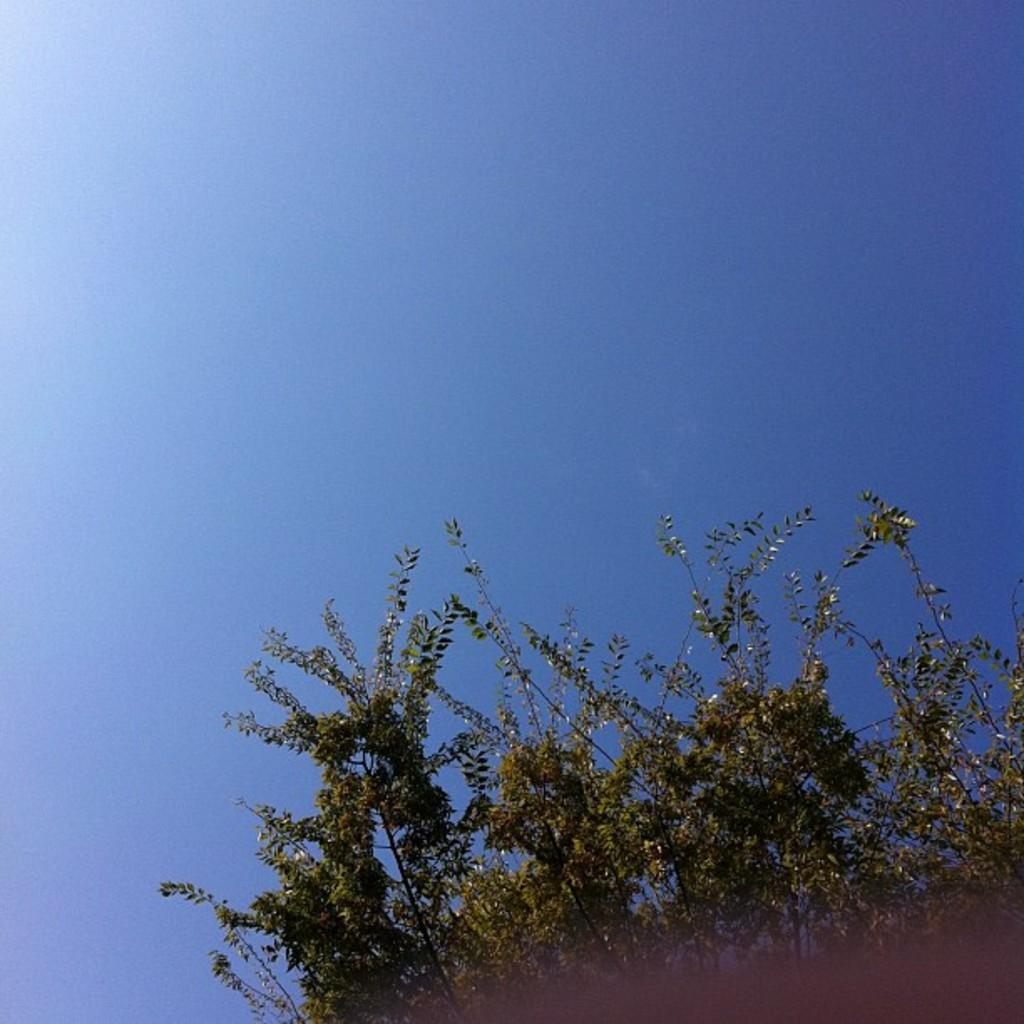What part of the natural environment can be seen in the image? The sky is visible in the image. What type of vegetation is present in the image? There are trees truncated towards the right of the image. What object is partially visible in the image? There is an object truncated towards the bottom of the image. Can you tell me how many eyes are visible in the image? There are no eyes present in the image. Is there a jail visible in the image? There is no jail present in the image. 